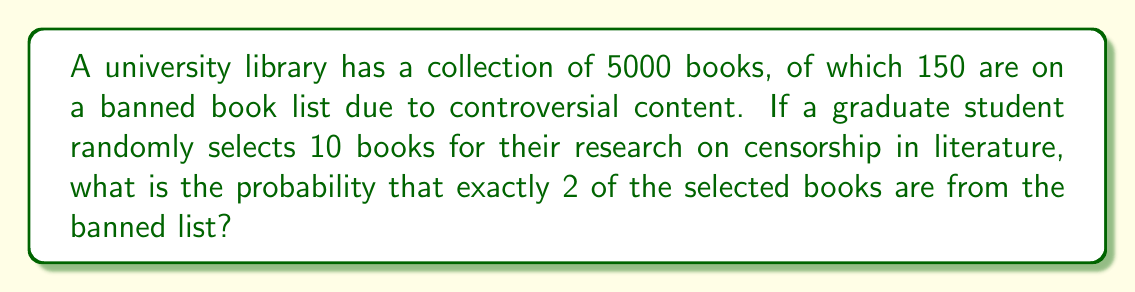Can you answer this question? To solve this problem, we can use the hypergeometric distribution, which is appropriate for sampling without replacement from a finite population.

Let's define our parameters:
- N = 5000 (total number of books)
- K = 150 (number of banned books)
- n = 10 (number of books selected)
- k = 2 (number of banned books we want in our selection)

The probability mass function for the hypergeometric distribution is:

$$ P(X = k) = \frac{\binom{K}{k} \binom{N-K}{n-k}}{\binom{N}{n}} $$

Substituting our values:

$$ P(X = 2) = \frac{\binom{150}{2} \binom{5000-150}{10-2}}{\binom{5000}{10}} $$

Let's calculate each part:

1) $\binom{150}{2} = \frac{150!}{2!(150-2)!} = \frac{150 \cdot 149}{2} = 11,175$

2) $\binom{4850}{8} = \frac{4850!}{8!(4850-8)!} = 1.3673 \times 10^{25}$

3) $\binom{5000}{10} = \frac{5000!}{10!(5000-10)!} = 2.7450 \times 10^{28}$

Now, let's put it all together:

$$ P(X = 2) = \frac{11,175 \cdot 1.3673 \times 10^{25}}{2.7450 \times 10^{28}} = 0.0557 $$

Therefore, the probability of selecting exactly 2 banned books out of 10 randomly selected books is approximately 0.0557 or 5.57%.
Answer: 0.0557 